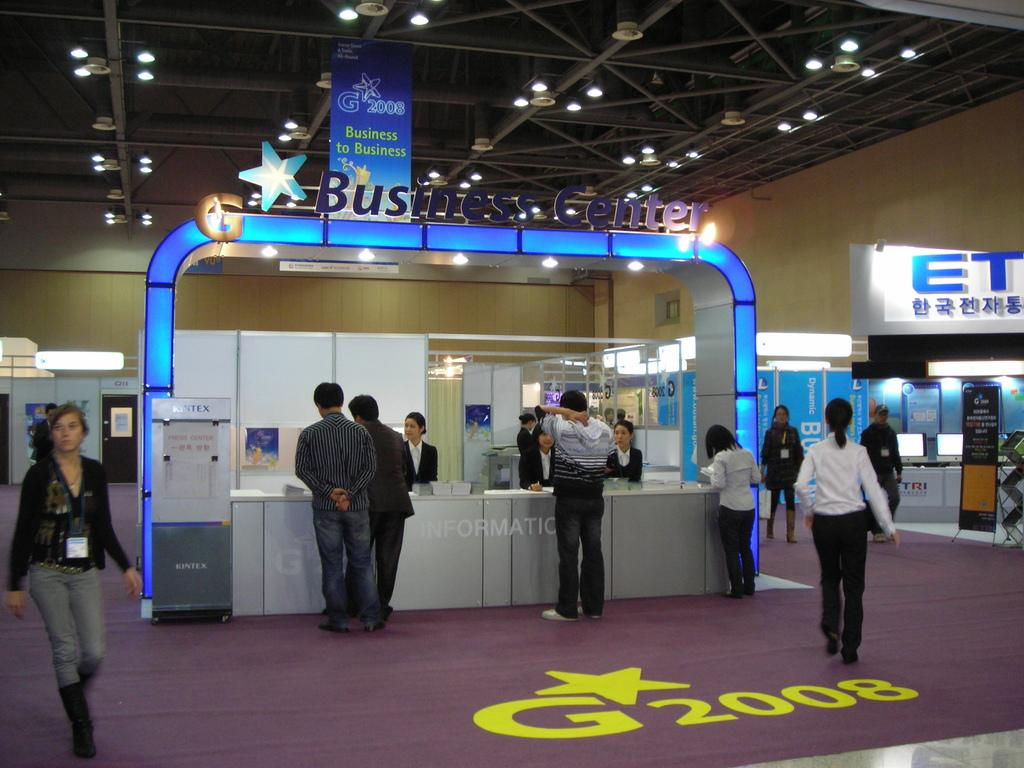What is the woman doing on the left side of the image? The woman is walking on the left side of the image. What are the people in the middle of the image doing? There is a group of people standing in the middle of the image. What can be seen on the hoarding in the image? There appears to be a hoarding with lights in the image. What is visible at the top of the image? There are lights visible at the top of the image. How many toes does the woman have on her right foot in the image? There is no information about the woman's toes in the image, so it cannot be determined. What type of education is being offered at the location in the image? There is no indication of any educational institution or activity in the image. What is the position of the sun in the image? The sun is not visible in the image, so its position cannot be determined. 